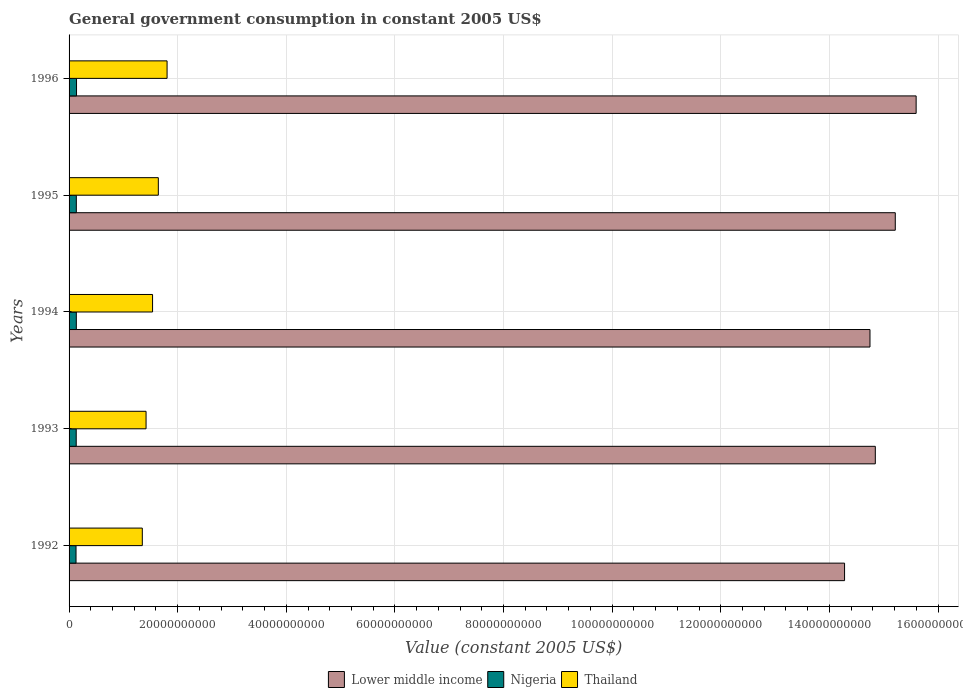Are the number of bars on each tick of the Y-axis equal?
Provide a short and direct response. Yes. How many bars are there on the 4th tick from the top?
Keep it short and to the point. 3. What is the label of the 2nd group of bars from the top?
Provide a short and direct response. 1995. In how many cases, is the number of bars for a given year not equal to the number of legend labels?
Give a very brief answer. 0. What is the government conusmption in Thailand in 1996?
Ensure brevity in your answer.  1.80e+1. Across all years, what is the maximum government conusmption in Lower middle income?
Your answer should be very brief. 1.56e+11. Across all years, what is the minimum government conusmption in Nigeria?
Make the answer very short. 1.28e+09. In which year was the government conusmption in Thailand maximum?
Keep it short and to the point. 1996. What is the total government conusmption in Lower middle income in the graph?
Your answer should be very brief. 7.47e+11. What is the difference between the government conusmption in Lower middle income in 1992 and that in 1996?
Offer a terse response. -1.32e+1. What is the difference between the government conusmption in Lower middle income in 1992 and the government conusmption in Thailand in 1996?
Give a very brief answer. 1.25e+11. What is the average government conusmption in Nigeria per year?
Your response must be concise. 1.33e+09. In the year 1994, what is the difference between the government conusmption in Thailand and government conusmption in Lower middle income?
Keep it short and to the point. -1.32e+11. In how many years, is the government conusmption in Nigeria greater than 96000000000 US$?
Your answer should be very brief. 0. What is the ratio of the government conusmption in Thailand in 1992 to that in 1993?
Give a very brief answer. 0.95. Is the difference between the government conusmption in Thailand in 1993 and 1995 greater than the difference between the government conusmption in Lower middle income in 1993 and 1995?
Provide a succinct answer. Yes. What is the difference between the highest and the second highest government conusmption in Nigeria?
Provide a short and direct response. 3.79e+07. What is the difference between the highest and the lowest government conusmption in Nigeria?
Offer a very short reply. 9.37e+07. Is the sum of the government conusmption in Thailand in 1994 and 1996 greater than the maximum government conusmption in Lower middle income across all years?
Your answer should be compact. No. What does the 3rd bar from the top in 1994 represents?
Provide a short and direct response. Lower middle income. What does the 3rd bar from the bottom in 1993 represents?
Ensure brevity in your answer.  Thailand. Is it the case that in every year, the sum of the government conusmption in Lower middle income and government conusmption in Nigeria is greater than the government conusmption in Thailand?
Keep it short and to the point. Yes. How many bars are there?
Offer a very short reply. 15. How many years are there in the graph?
Offer a terse response. 5. Does the graph contain grids?
Offer a very short reply. Yes. How many legend labels are there?
Provide a succinct answer. 3. How are the legend labels stacked?
Provide a short and direct response. Horizontal. What is the title of the graph?
Give a very brief answer. General government consumption in constant 2005 US$. Does "Eritrea" appear as one of the legend labels in the graph?
Offer a terse response. No. What is the label or title of the X-axis?
Make the answer very short. Value (constant 2005 US$). What is the label or title of the Y-axis?
Keep it short and to the point. Years. What is the Value (constant 2005 US$) in Lower middle income in 1992?
Ensure brevity in your answer.  1.43e+11. What is the Value (constant 2005 US$) in Nigeria in 1992?
Provide a short and direct response. 1.28e+09. What is the Value (constant 2005 US$) in Thailand in 1992?
Offer a terse response. 1.35e+1. What is the Value (constant 2005 US$) of Lower middle income in 1993?
Your response must be concise. 1.48e+11. What is the Value (constant 2005 US$) in Nigeria in 1993?
Give a very brief answer. 1.32e+09. What is the Value (constant 2005 US$) in Thailand in 1993?
Keep it short and to the point. 1.42e+1. What is the Value (constant 2005 US$) of Lower middle income in 1994?
Offer a terse response. 1.47e+11. What is the Value (constant 2005 US$) in Nigeria in 1994?
Your answer should be very brief. 1.34e+09. What is the Value (constant 2005 US$) in Thailand in 1994?
Provide a succinct answer. 1.54e+1. What is the Value (constant 2005 US$) of Lower middle income in 1995?
Offer a terse response. 1.52e+11. What is the Value (constant 2005 US$) of Nigeria in 1995?
Offer a very short reply. 1.34e+09. What is the Value (constant 2005 US$) of Thailand in 1995?
Your answer should be compact. 1.64e+1. What is the Value (constant 2005 US$) of Lower middle income in 1996?
Your answer should be compact. 1.56e+11. What is the Value (constant 2005 US$) of Nigeria in 1996?
Ensure brevity in your answer.  1.37e+09. What is the Value (constant 2005 US$) of Thailand in 1996?
Keep it short and to the point. 1.80e+1. Across all years, what is the maximum Value (constant 2005 US$) in Lower middle income?
Provide a succinct answer. 1.56e+11. Across all years, what is the maximum Value (constant 2005 US$) in Nigeria?
Ensure brevity in your answer.  1.37e+09. Across all years, what is the maximum Value (constant 2005 US$) of Thailand?
Ensure brevity in your answer.  1.80e+1. Across all years, what is the minimum Value (constant 2005 US$) in Lower middle income?
Offer a terse response. 1.43e+11. Across all years, what is the minimum Value (constant 2005 US$) in Nigeria?
Your answer should be very brief. 1.28e+09. Across all years, what is the minimum Value (constant 2005 US$) in Thailand?
Offer a very short reply. 1.35e+1. What is the total Value (constant 2005 US$) in Lower middle income in the graph?
Your response must be concise. 7.47e+11. What is the total Value (constant 2005 US$) in Nigeria in the graph?
Keep it short and to the point. 6.64e+09. What is the total Value (constant 2005 US$) in Thailand in the graph?
Offer a terse response. 7.75e+1. What is the difference between the Value (constant 2005 US$) of Lower middle income in 1992 and that in 1993?
Give a very brief answer. -5.66e+09. What is the difference between the Value (constant 2005 US$) of Nigeria in 1992 and that in 1993?
Make the answer very short. -3.71e+07. What is the difference between the Value (constant 2005 US$) of Thailand in 1992 and that in 1993?
Provide a succinct answer. -6.90e+08. What is the difference between the Value (constant 2005 US$) of Lower middle income in 1992 and that in 1994?
Your answer should be compact. -4.68e+09. What is the difference between the Value (constant 2005 US$) in Nigeria in 1992 and that in 1994?
Your response must be concise. -5.59e+07. What is the difference between the Value (constant 2005 US$) of Thailand in 1992 and that in 1994?
Your response must be concise. -1.89e+09. What is the difference between the Value (constant 2005 US$) of Lower middle income in 1992 and that in 1995?
Provide a short and direct response. -9.34e+09. What is the difference between the Value (constant 2005 US$) of Nigeria in 1992 and that in 1995?
Your answer should be very brief. -5.51e+07. What is the difference between the Value (constant 2005 US$) of Thailand in 1992 and that in 1995?
Make the answer very short. -2.95e+09. What is the difference between the Value (constant 2005 US$) of Lower middle income in 1992 and that in 1996?
Your answer should be very brief. -1.32e+1. What is the difference between the Value (constant 2005 US$) in Nigeria in 1992 and that in 1996?
Keep it short and to the point. -9.37e+07. What is the difference between the Value (constant 2005 US$) of Thailand in 1992 and that in 1996?
Your response must be concise. -4.56e+09. What is the difference between the Value (constant 2005 US$) of Lower middle income in 1993 and that in 1994?
Your answer should be very brief. 9.81e+08. What is the difference between the Value (constant 2005 US$) in Nigeria in 1993 and that in 1994?
Offer a terse response. -1.88e+07. What is the difference between the Value (constant 2005 US$) of Thailand in 1993 and that in 1994?
Ensure brevity in your answer.  -1.20e+09. What is the difference between the Value (constant 2005 US$) of Lower middle income in 1993 and that in 1995?
Your response must be concise. -3.68e+09. What is the difference between the Value (constant 2005 US$) in Nigeria in 1993 and that in 1995?
Offer a very short reply. -1.80e+07. What is the difference between the Value (constant 2005 US$) in Thailand in 1993 and that in 1995?
Give a very brief answer. -2.26e+09. What is the difference between the Value (constant 2005 US$) in Lower middle income in 1993 and that in 1996?
Ensure brevity in your answer.  -7.52e+09. What is the difference between the Value (constant 2005 US$) of Nigeria in 1993 and that in 1996?
Keep it short and to the point. -5.67e+07. What is the difference between the Value (constant 2005 US$) of Thailand in 1993 and that in 1996?
Your answer should be compact. -3.87e+09. What is the difference between the Value (constant 2005 US$) of Lower middle income in 1994 and that in 1995?
Provide a short and direct response. -4.66e+09. What is the difference between the Value (constant 2005 US$) in Nigeria in 1994 and that in 1995?
Your response must be concise. 7.81e+05. What is the difference between the Value (constant 2005 US$) in Thailand in 1994 and that in 1995?
Your answer should be compact. -1.06e+09. What is the difference between the Value (constant 2005 US$) of Lower middle income in 1994 and that in 1996?
Ensure brevity in your answer.  -8.50e+09. What is the difference between the Value (constant 2005 US$) of Nigeria in 1994 and that in 1996?
Your answer should be very brief. -3.79e+07. What is the difference between the Value (constant 2005 US$) in Thailand in 1994 and that in 1996?
Give a very brief answer. -2.67e+09. What is the difference between the Value (constant 2005 US$) of Lower middle income in 1995 and that in 1996?
Your answer should be compact. -3.84e+09. What is the difference between the Value (constant 2005 US$) of Nigeria in 1995 and that in 1996?
Your response must be concise. -3.86e+07. What is the difference between the Value (constant 2005 US$) of Thailand in 1995 and that in 1996?
Provide a succinct answer. -1.61e+09. What is the difference between the Value (constant 2005 US$) of Lower middle income in 1992 and the Value (constant 2005 US$) of Nigeria in 1993?
Your response must be concise. 1.41e+11. What is the difference between the Value (constant 2005 US$) of Lower middle income in 1992 and the Value (constant 2005 US$) of Thailand in 1993?
Your answer should be compact. 1.29e+11. What is the difference between the Value (constant 2005 US$) of Nigeria in 1992 and the Value (constant 2005 US$) of Thailand in 1993?
Keep it short and to the point. -1.29e+1. What is the difference between the Value (constant 2005 US$) of Lower middle income in 1992 and the Value (constant 2005 US$) of Nigeria in 1994?
Provide a succinct answer. 1.41e+11. What is the difference between the Value (constant 2005 US$) of Lower middle income in 1992 and the Value (constant 2005 US$) of Thailand in 1994?
Give a very brief answer. 1.27e+11. What is the difference between the Value (constant 2005 US$) of Nigeria in 1992 and the Value (constant 2005 US$) of Thailand in 1994?
Provide a succinct answer. -1.41e+1. What is the difference between the Value (constant 2005 US$) in Lower middle income in 1992 and the Value (constant 2005 US$) in Nigeria in 1995?
Offer a terse response. 1.41e+11. What is the difference between the Value (constant 2005 US$) in Lower middle income in 1992 and the Value (constant 2005 US$) in Thailand in 1995?
Your response must be concise. 1.26e+11. What is the difference between the Value (constant 2005 US$) in Nigeria in 1992 and the Value (constant 2005 US$) in Thailand in 1995?
Provide a succinct answer. -1.52e+1. What is the difference between the Value (constant 2005 US$) of Lower middle income in 1992 and the Value (constant 2005 US$) of Nigeria in 1996?
Give a very brief answer. 1.41e+11. What is the difference between the Value (constant 2005 US$) in Lower middle income in 1992 and the Value (constant 2005 US$) in Thailand in 1996?
Your response must be concise. 1.25e+11. What is the difference between the Value (constant 2005 US$) of Nigeria in 1992 and the Value (constant 2005 US$) of Thailand in 1996?
Provide a succinct answer. -1.68e+1. What is the difference between the Value (constant 2005 US$) of Lower middle income in 1993 and the Value (constant 2005 US$) of Nigeria in 1994?
Give a very brief answer. 1.47e+11. What is the difference between the Value (constant 2005 US$) in Lower middle income in 1993 and the Value (constant 2005 US$) in Thailand in 1994?
Offer a very short reply. 1.33e+11. What is the difference between the Value (constant 2005 US$) in Nigeria in 1993 and the Value (constant 2005 US$) in Thailand in 1994?
Offer a very short reply. -1.41e+1. What is the difference between the Value (constant 2005 US$) of Lower middle income in 1993 and the Value (constant 2005 US$) of Nigeria in 1995?
Offer a terse response. 1.47e+11. What is the difference between the Value (constant 2005 US$) in Lower middle income in 1993 and the Value (constant 2005 US$) in Thailand in 1995?
Make the answer very short. 1.32e+11. What is the difference between the Value (constant 2005 US$) of Nigeria in 1993 and the Value (constant 2005 US$) of Thailand in 1995?
Make the answer very short. -1.51e+1. What is the difference between the Value (constant 2005 US$) in Lower middle income in 1993 and the Value (constant 2005 US$) in Nigeria in 1996?
Offer a very short reply. 1.47e+11. What is the difference between the Value (constant 2005 US$) of Lower middle income in 1993 and the Value (constant 2005 US$) of Thailand in 1996?
Your answer should be compact. 1.30e+11. What is the difference between the Value (constant 2005 US$) of Nigeria in 1993 and the Value (constant 2005 US$) of Thailand in 1996?
Your answer should be compact. -1.67e+1. What is the difference between the Value (constant 2005 US$) of Lower middle income in 1994 and the Value (constant 2005 US$) of Nigeria in 1995?
Provide a short and direct response. 1.46e+11. What is the difference between the Value (constant 2005 US$) of Lower middle income in 1994 and the Value (constant 2005 US$) of Thailand in 1995?
Your answer should be compact. 1.31e+11. What is the difference between the Value (constant 2005 US$) in Nigeria in 1994 and the Value (constant 2005 US$) in Thailand in 1995?
Your answer should be very brief. -1.51e+1. What is the difference between the Value (constant 2005 US$) of Lower middle income in 1994 and the Value (constant 2005 US$) of Nigeria in 1996?
Provide a succinct answer. 1.46e+11. What is the difference between the Value (constant 2005 US$) in Lower middle income in 1994 and the Value (constant 2005 US$) in Thailand in 1996?
Offer a terse response. 1.29e+11. What is the difference between the Value (constant 2005 US$) in Nigeria in 1994 and the Value (constant 2005 US$) in Thailand in 1996?
Provide a succinct answer. -1.67e+1. What is the difference between the Value (constant 2005 US$) of Lower middle income in 1995 and the Value (constant 2005 US$) of Nigeria in 1996?
Your answer should be very brief. 1.51e+11. What is the difference between the Value (constant 2005 US$) in Lower middle income in 1995 and the Value (constant 2005 US$) in Thailand in 1996?
Offer a terse response. 1.34e+11. What is the difference between the Value (constant 2005 US$) of Nigeria in 1995 and the Value (constant 2005 US$) of Thailand in 1996?
Offer a terse response. -1.67e+1. What is the average Value (constant 2005 US$) of Lower middle income per year?
Provide a short and direct response. 1.49e+11. What is the average Value (constant 2005 US$) of Nigeria per year?
Your answer should be compact. 1.33e+09. What is the average Value (constant 2005 US$) in Thailand per year?
Provide a short and direct response. 1.55e+1. In the year 1992, what is the difference between the Value (constant 2005 US$) of Lower middle income and Value (constant 2005 US$) of Nigeria?
Give a very brief answer. 1.42e+11. In the year 1992, what is the difference between the Value (constant 2005 US$) in Lower middle income and Value (constant 2005 US$) in Thailand?
Offer a very short reply. 1.29e+11. In the year 1992, what is the difference between the Value (constant 2005 US$) of Nigeria and Value (constant 2005 US$) of Thailand?
Your answer should be very brief. -1.22e+1. In the year 1993, what is the difference between the Value (constant 2005 US$) in Lower middle income and Value (constant 2005 US$) in Nigeria?
Offer a terse response. 1.47e+11. In the year 1993, what is the difference between the Value (constant 2005 US$) of Lower middle income and Value (constant 2005 US$) of Thailand?
Provide a succinct answer. 1.34e+11. In the year 1993, what is the difference between the Value (constant 2005 US$) of Nigeria and Value (constant 2005 US$) of Thailand?
Your response must be concise. -1.29e+1. In the year 1994, what is the difference between the Value (constant 2005 US$) in Lower middle income and Value (constant 2005 US$) in Nigeria?
Give a very brief answer. 1.46e+11. In the year 1994, what is the difference between the Value (constant 2005 US$) of Lower middle income and Value (constant 2005 US$) of Thailand?
Your answer should be compact. 1.32e+11. In the year 1994, what is the difference between the Value (constant 2005 US$) in Nigeria and Value (constant 2005 US$) in Thailand?
Your answer should be very brief. -1.40e+1. In the year 1995, what is the difference between the Value (constant 2005 US$) in Lower middle income and Value (constant 2005 US$) in Nigeria?
Offer a very short reply. 1.51e+11. In the year 1995, what is the difference between the Value (constant 2005 US$) in Lower middle income and Value (constant 2005 US$) in Thailand?
Give a very brief answer. 1.36e+11. In the year 1995, what is the difference between the Value (constant 2005 US$) of Nigeria and Value (constant 2005 US$) of Thailand?
Ensure brevity in your answer.  -1.51e+1. In the year 1996, what is the difference between the Value (constant 2005 US$) of Lower middle income and Value (constant 2005 US$) of Nigeria?
Your answer should be compact. 1.55e+11. In the year 1996, what is the difference between the Value (constant 2005 US$) of Lower middle income and Value (constant 2005 US$) of Thailand?
Ensure brevity in your answer.  1.38e+11. In the year 1996, what is the difference between the Value (constant 2005 US$) in Nigeria and Value (constant 2005 US$) in Thailand?
Offer a very short reply. -1.67e+1. What is the ratio of the Value (constant 2005 US$) of Lower middle income in 1992 to that in 1993?
Make the answer very short. 0.96. What is the ratio of the Value (constant 2005 US$) of Nigeria in 1992 to that in 1993?
Provide a short and direct response. 0.97. What is the ratio of the Value (constant 2005 US$) of Thailand in 1992 to that in 1993?
Keep it short and to the point. 0.95. What is the ratio of the Value (constant 2005 US$) of Lower middle income in 1992 to that in 1994?
Ensure brevity in your answer.  0.97. What is the ratio of the Value (constant 2005 US$) of Nigeria in 1992 to that in 1994?
Provide a succinct answer. 0.96. What is the ratio of the Value (constant 2005 US$) of Thailand in 1992 to that in 1994?
Your response must be concise. 0.88. What is the ratio of the Value (constant 2005 US$) in Lower middle income in 1992 to that in 1995?
Make the answer very short. 0.94. What is the ratio of the Value (constant 2005 US$) of Nigeria in 1992 to that in 1995?
Offer a terse response. 0.96. What is the ratio of the Value (constant 2005 US$) in Thailand in 1992 to that in 1995?
Your answer should be very brief. 0.82. What is the ratio of the Value (constant 2005 US$) of Lower middle income in 1992 to that in 1996?
Your response must be concise. 0.92. What is the ratio of the Value (constant 2005 US$) in Nigeria in 1992 to that in 1996?
Your answer should be compact. 0.93. What is the ratio of the Value (constant 2005 US$) of Thailand in 1992 to that in 1996?
Offer a terse response. 0.75. What is the ratio of the Value (constant 2005 US$) in Nigeria in 1993 to that in 1994?
Make the answer very short. 0.99. What is the ratio of the Value (constant 2005 US$) in Thailand in 1993 to that in 1994?
Provide a succinct answer. 0.92. What is the ratio of the Value (constant 2005 US$) in Lower middle income in 1993 to that in 1995?
Your answer should be very brief. 0.98. What is the ratio of the Value (constant 2005 US$) in Nigeria in 1993 to that in 1995?
Keep it short and to the point. 0.99. What is the ratio of the Value (constant 2005 US$) of Thailand in 1993 to that in 1995?
Your response must be concise. 0.86. What is the ratio of the Value (constant 2005 US$) of Lower middle income in 1993 to that in 1996?
Give a very brief answer. 0.95. What is the ratio of the Value (constant 2005 US$) of Nigeria in 1993 to that in 1996?
Give a very brief answer. 0.96. What is the ratio of the Value (constant 2005 US$) of Thailand in 1993 to that in 1996?
Ensure brevity in your answer.  0.79. What is the ratio of the Value (constant 2005 US$) of Lower middle income in 1994 to that in 1995?
Your answer should be compact. 0.97. What is the ratio of the Value (constant 2005 US$) in Thailand in 1994 to that in 1995?
Provide a succinct answer. 0.94. What is the ratio of the Value (constant 2005 US$) in Lower middle income in 1994 to that in 1996?
Your answer should be very brief. 0.95. What is the ratio of the Value (constant 2005 US$) in Nigeria in 1994 to that in 1996?
Give a very brief answer. 0.97. What is the ratio of the Value (constant 2005 US$) of Thailand in 1994 to that in 1996?
Offer a very short reply. 0.85. What is the ratio of the Value (constant 2005 US$) in Lower middle income in 1995 to that in 1996?
Your answer should be compact. 0.98. What is the ratio of the Value (constant 2005 US$) in Nigeria in 1995 to that in 1996?
Keep it short and to the point. 0.97. What is the ratio of the Value (constant 2005 US$) of Thailand in 1995 to that in 1996?
Provide a succinct answer. 0.91. What is the difference between the highest and the second highest Value (constant 2005 US$) of Lower middle income?
Provide a short and direct response. 3.84e+09. What is the difference between the highest and the second highest Value (constant 2005 US$) in Nigeria?
Offer a terse response. 3.79e+07. What is the difference between the highest and the second highest Value (constant 2005 US$) of Thailand?
Your response must be concise. 1.61e+09. What is the difference between the highest and the lowest Value (constant 2005 US$) of Lower middle income?
Provide a succinct answer. 1.32e+1. What is the difference between the highest and the lowest Value (constant 2005 US$) of Nigeria?
Your answer should be very brief. 9.37e+07. What is the difference between the highest and the lowest Value (constant 2005 US$) of Thailand?
Provide a succinct answer. 4.56e+09. 